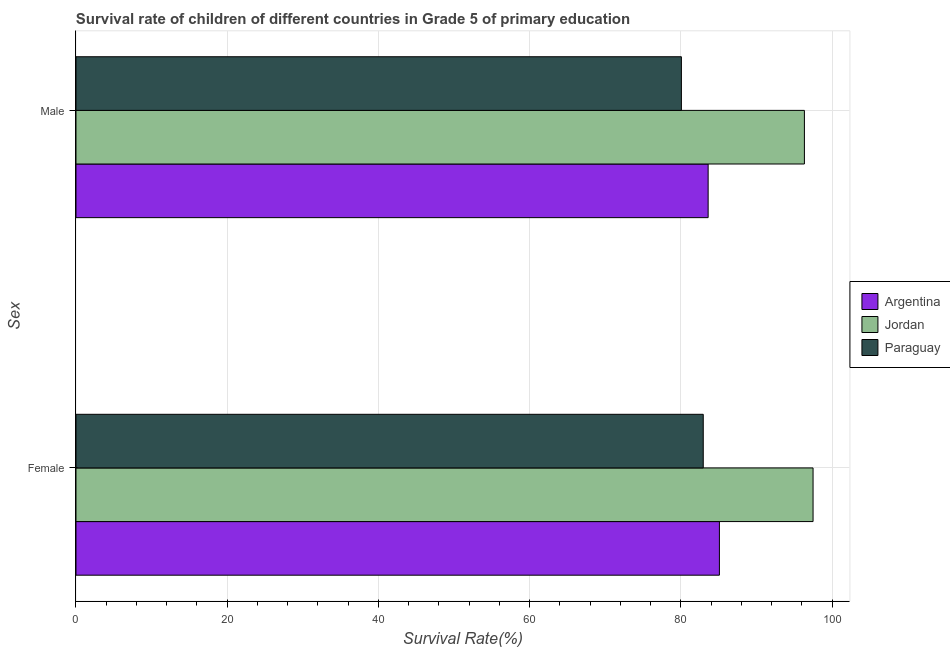How many different coloured bars are there?
Keep it short and to the point. 3. How many groups of bars are there?
Ensure brevity in your answer.  2. Are the number of bars per tick equal to the number of legend labels?
Offer a very short reply. Yes. Are the number of bars on each tick of the Y-axis equal?
Your response must be concise. Yes. How many bars are there on the 1st tick from the bottom?
Your answer should be very brief. 3. What is the survival rate of male students in primary education in Jordan?
Your response must be concise. 96.32. Across all countries, what is the maximum survival rate of male students in primary education?
Offer a very short reply. 96.32. Across all countries, what is the minimum survival rate of male students in primary education?
Give a very brief answer. 80.05. In which country was the survival rate of female students in primary education maximum?
Provide a succinct answer. Jordan. In which country was the survival rate of female students in primary education minimum?
Keep it short and to the point. Paraguay. What is the total survival rate of female students in primary education in the graph?
Offer a very short reply. 265.49. What is the difference between the survival rate of male students in primary education in Argentina and that in Paraguay?
Your answer should be compact. 3.54. What is the difference between the survival rate of male students in primary education in Paraguay and the survival rate of female students in primary education in Jordan?
Provide a short and direct response. -17.41. What is the average survival rate of female students in primary education per country?
Keep it short and to the point. 88.5. What is the difference between the survival rate of male students in primary education and survival rate of female students in primary education in Paraguay?
Keep it short and to the point. -2.89. In how many countries, is the survival rate of female students in primary education greater than 4 %?
Your answer should be compact. 3. What is the ratio of the survival rate of female students in primary education in Argentina to that in Paraguay?
Offer a very short reply. 1.03. Is the survival rate of female students in primary education in Paraguay less than that in Jordan?
Ensure brevity in your answer.  Yes. What does the 3rd bar from the top in Male represents?
Your answer should be compact. Argentina. How many bars are there?
Keep it short and to the point. 6. What is the difference between two consecutive major ticks on the X-axis?
Provide a succinct answer. 20. Are the values on the major ticks of X-axis written in scientific E-notation?
Make the answer very short. No. How are the legend labels stacked?
Keep it short and to the point. Vertical. What is the title of the graph?
Ensure brevity in your answer.  Survival rate of children of different countries in Grade 5 of primary education. What is the label or title of the X-axis?
Provide a succinct answer. Survival Rate(%). What is the label or title of the Y-axis?
Make the answer very short. Sex. What is the Survival Rate(%) of Argentina in Female?
Offer a very short reply. 85.08. What is the Survival Rate(%) of Jordan in Female?
Offer a terse response. 97.47. What is the Survival Rate(%) in Paraguay in Female?
Provide a succinct answer. 82.94. What is the Survival Rate(%) in Argentina in Male?
Offer a terse response. 83.59. What is the Survival Rate(%) in Jordan in Male?
Offer a very short reply. 96.32. What is the Survival Rate(%) in Paraguay in Male?
Your response must be concise. 80.05. Across all Sex, what is the maximum Survival Rate(%) in Argentina?
Ensure brevity in your answer.  85.08. Across all Sex, what is the maximum Survival Rate(%) of Jordan?
Make the answer very short. 97.47. Across all Sex, what is the maximum Survival Rate(%) of Paraguay?
Keep it short and to the point. 82.94. Across all Sex, what is the minimum Survival Rate(%) of Argentina?
Your answer should be compact. 83.59. Across all Sex, what is the minimum Survival Rate(%) in Jordan?
Keep it short and to the point. 96.32. Across all Sex, what is the minimum Survival Rate(%) in Paraguay?
Keep it short and to the point. 80.05. What is the total Survival Rate(%) of Argentina in the graph?
Provide a succinct answer. 168.67. What is the total Survival Rate(%) of Jordan in the graph?
Your answer should be compact. 193.79. What is the total Survival Rate(%) in Paraguay in the graph?
Keep it short and to the point. 163. What is the difference between the Survival Rate(%) in Argentina in Female and that in Male?
Keep it short and to the point. 1.49. What is the difference between the Survival Rate(%) in Jordan in Female and that in Male?
Keep it short and to the point. 1.14. What is the difference between the Survival Rate(%) of Paraguay in Female and that in Male?
Provide a short and direct response. 2.89. What is the difference between the Survival Rate(%) of Argentina in Female and the Survival Rate(%) of Jordan in Male?
Offer a very short reply. -11.24. What is the difference between the Survival Rate(%) in Argentina in Female and the Survival Rate(%) in Paraguay in Male?
Keep it short and to the point. 5.03. What is the difference between the Survival Rate(%) in Jordan in Female and the Survival Rate(%) in Paraguay in Male?
Your answer should be very brief. 17.41. What is the average Survival Rate(%) of Argentina per Sex?
Give a very brief answer. 84.34. What is the average Survival Rate(%) of Jordan per Sex?
Give a very brief answer. 96.89. What is the average Survival Rate(%) of Paraguay per Sex?
Your answer should be very brief. 81.5. What is the difference between the Survival Rate(%) in Argentina and Survival Rate(%) in Jordan in Female?
Offer a terse response. -12.38. What is the difference between the Survival Rate(%) in Argentina and Survival Rate(%) in Paraguay in Female?
Provide a succinct answer. 2.14. What is the difference between the Survival Rate(%) in Jordan and Survival Rate(%) in Paraguay in Female?
Provide a succinct answer. 14.52. What is the difference between the Survival Rate(%) in Argentina and Survival Rate(%) in Jordan in Male?
Offer a terse response. -12.73. What is the difference between the Survival Rate(%) of Argentina and Survival Rate(%) of Paraguay in Male?
Provide a succinct answer. 3.54. What is the difference between the Survival Rate(%) in Jordan and Survival Rate(%) in Paraguay in Male?
Make the answer very short. 16.27. What is the ratio of the Survival Rate(%) of Argentina in Female to that in Male?
Provide a succinct answer. 1.02. What is the ratio of the Survival Rate(%) in Jordan in Female to that in Male?
Your answer should be compact. 1.01. What is the ratio of the Survival Rate(%) of Paraguay in Female to that in Male?
Keep it short and to the point. 1.04. What is the difference between the highest and the second highest Survival Rate(%) of Argentina?
Provide a short and direct response. 1.49. What is the difference between the highest and the second highest Survival Rate(%) of Jordan?
Your answer should be compact. 1.14. What is the difference between the highest and the second highest Survival Rate(%) of Paraguay?
Offer a very short reply. 2.89. What is the difference between the highest and the lowest Survival Rate(%) of Argentina?
Keep it short and to the point. 1.49. What is the difference between the highest and the lowest Survival Rate(%) in Jordan?
Keep it short and to the point. 1.14. What is the difference between the highest and the lowest Survival Rate(%) of Paraguay?
Make the answer very short. 2.89. 